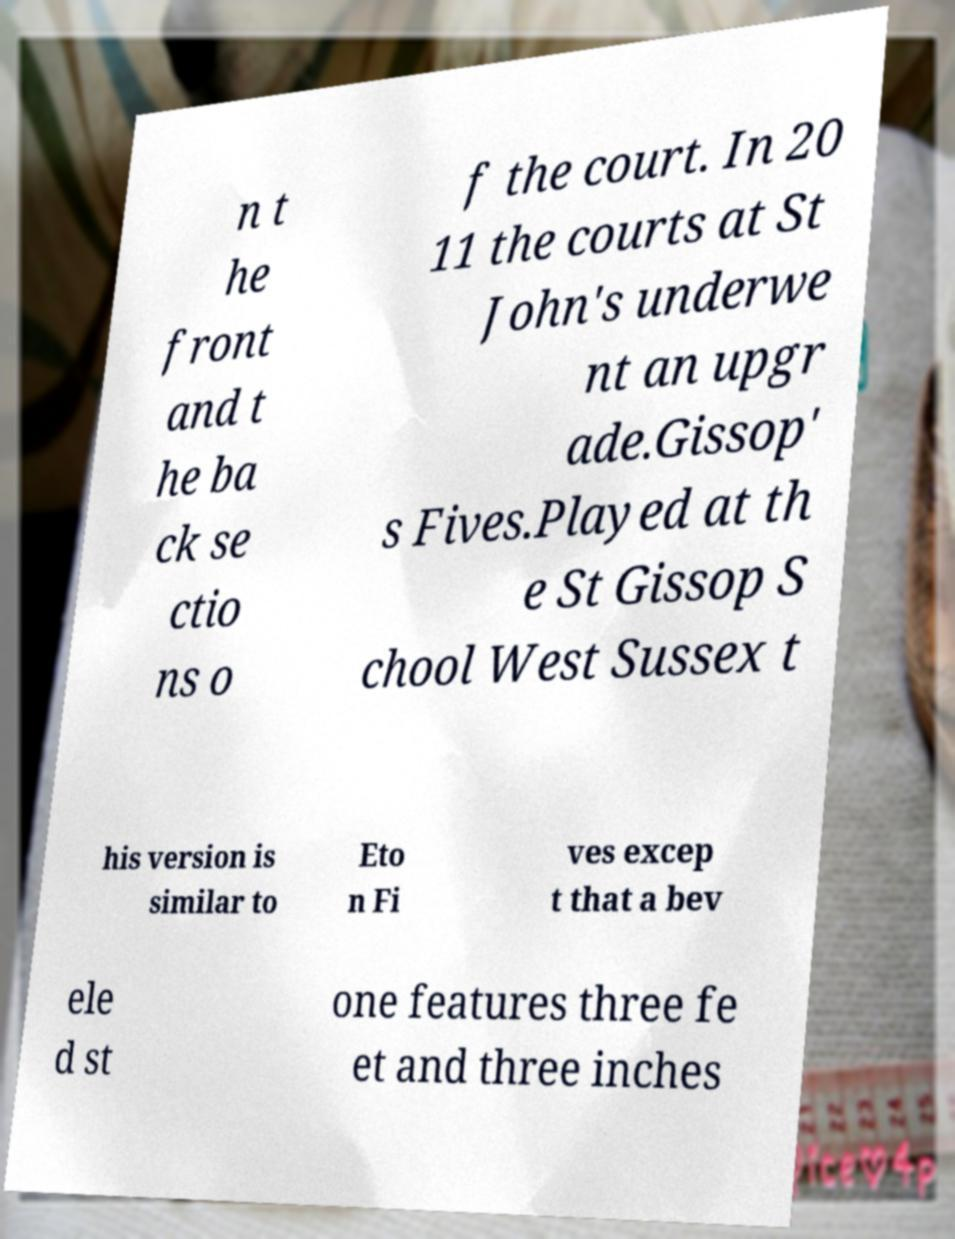There's text embedded in this image that I need extracted. Can you transcribe it verbatim? n t he front and t he ba ck se ctio ns o f the court. In 20 11 the courts at St John's underwe nt an upgr ade.Gissop' s Fives.Played at th e St Gissop S chool West Sussex t his version is similar to Eto n Fi ves excep t that a bev ele d st one features three fe et and three inches 